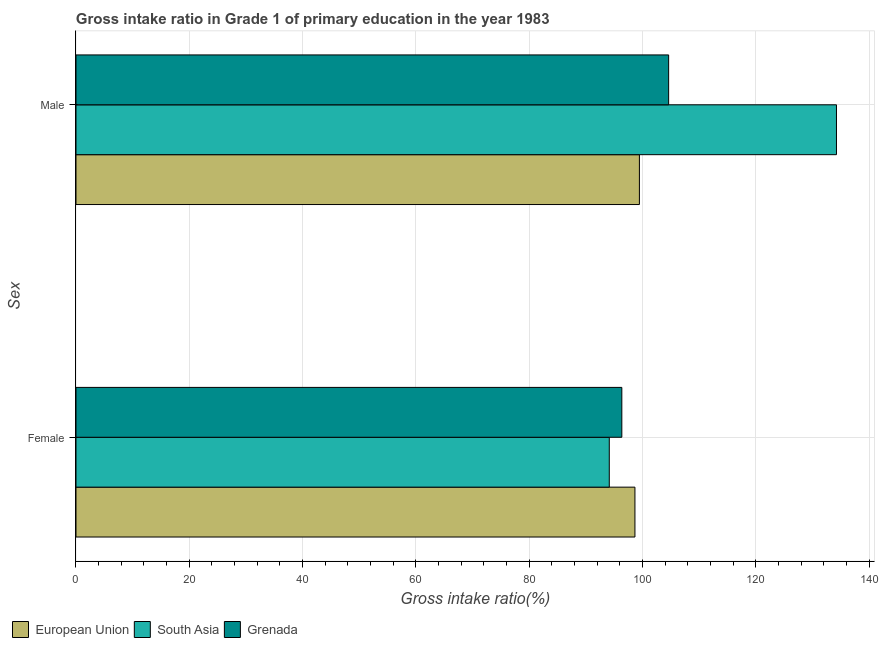How many different coloured bars are there?
Ensure brevity in your answer.  3. How many groups of bars are there?
Give a very brief answer. 2. Are the number of bars per tick equal to the number of legend labels?
Offer a terse response. Yes. Are the number of bars on each tick of the Y-axis equal?
Offer a very short reply. Yes. How many bars are there on the 2nd tick from the bottom?
Your response must be concise. 3. What is the label of the 2nd group of bars from the top?
Your answer should be very brief. Female. What is the gross intake ratio(female) in Grenada?
Your response must be concise. 96.35. Across all countries, what is the maximum gross intake ratio(male)?
Make the answer very short. 134.24. Across all countries, what is the minimum gross intake ratio(male)?
Offer a very short reply. 99.46. In which country was the gross intake ratio(female) minimum?
Your answer should be compact. South Asia. What is the total gross intake ratio(male) in the graph?
Offer a terse response. 338.32. What is the difference between the gross intake ratio(female) in European Union and that in South Asia?
Your answer should be compact. 4.53. What is the difference between the gross intake ratio(female) in European Union and the gross intake ratio(male) in Grenada?
Your response must be concise. -5.95. What is the average gross intake ratio(male) per country?
Provide a succinct answer. 112.77. What is the difference between the gross intake ratio(female) and gross intake ratio(male) in South Asia?
Your response must be concise. -40.11. In how many countries, is the gross intake ratio(male) greater than 16 %?
Provide a short and direct response. 3. What is the ratio of the gross intake ratio(male) in European Union to that in South Asia?
Your response must be concise. 0.74. What does the 3rd bar from the top in Female represents?
Provide a succinct answer. European Union. How many countries are there in the graph?
Give a very brief answer. 3. What is the difference between two consecutive major ticks on the X-axis?
Your response must be concise. 20. Are the values on the major ticks of X-axis written in scientific E-notation?
Give a very brief answer. No. What is the title of the graph?
Make the answer very short. Gross intake ratio in Grade 1 of primary education in the year 1983. Does "Swaziland" appear as one of the legend labels in the graph?
Offer a terse response. No. What is the label or title of the X-axis?
Offer a terse response. Gross intake ratio(%). What is the label or title of the Y-axis?
Your response must be concise. Sex. What is the Gross intake ratio(%) of European Union in Female?
Your answer should be very brief. 98.67. What is the Gross intake ratio(%) in South Asia in Female?
Keep it short and to the point. 94.14. What is the Gross intake ratio(%) in Grenada in Female?
Offer a very short reply. 96.35. What is the Gross intake ratio(%) in European Union in Male?
Provide a succinct answer. 99.46. What is the Gross intake ratio(%) of South Asia in Male?
Provide a succinct answer. 134.24. What is the Gross intake ratio(%) of Grenada in Male?
Your response must be concise. 104.62. Across all Sex, what is the maximum Gross intake ratio(%) in European Union?
Your response must be concise. 99.46. Across all Sex, what is the maximum Gross intake ratio(%) in South Asia?
Provide a short and direct response. 134.24. Across all Sex, what is the maximum Gross intake ratio(%) of Grenada?
Keep it short and to the point. 104.62. Across all Sex, what is the minimum Gross intake ratio(%) in European Union?
Ensure brevity in your answer.  98.67. Across all Sex, what is the minimum Gross intake ratio(%) of South Asia?
Provide a succinct answer. 94.14. Across all Sex, what is the minimum Gross intake ratio(%) of Grenada?
Keep it short and to the point. 96.35. What is the total Gross intake ratio(%) of European Union in the graph?
Make the answer very short. 198.13. What is the total Gross intake ratio(%) of South Asia in the graph?
Your response must be concise. 228.38. What is the total Gross intake ratio(%) in Grenada in the graph?
Give a very brief answer. 200.97. What is the difference between the Gross intake ratio(%) in European Union in Female and that in Male?
Keep it short and to the point. -0.79. What is the difference between the Gross intake ratio(%) in South Asia in Female and that in Male?
Your response must be concise. -40.11. What is the difference between the Gross intake ratio(%) of Grenada in Female and that in Male?
Offer a very short reply. -8.26. What is the difference between the Gross intake ratio(%) in European Union in Female and the Gross intake ratio(%) in South Asia in Male?
Keep it short and to the point. -35.58. What is the difference between the Gross intake ratio(%) of European Union in Female and the Gross intake ratio(%) of Grenada in Male?
Your answer should be compact. -5.95. What is the difference between the Gross intake ratio(%) of South Asia in Female and the Gross intake ratio(%) of Grenada in Male?
Your answer should be compact. -10.48. What is the average Gross intake ratio(%) of European Union per Sex?
Ensure brevity in your answer.  99.06. What is the average Gross intake ratio(%) of South Asia per Sex?
Make the answer very short. 114.19. What is the average Gross intake ratio(%) in Grenada per Sex?
Offer a terse response. 100.49. What is the difference between the Gross intake ratio(%) of European Union and Gross intake ratio(%) of South Asia in Female?
Keep it short and to the point. 4.53. What is the difference between the Gross intake ratio(%) in European Union and Gross intake ratio(%) in Grenada in Female?
Ensure brevity in your answer.  2.31. What is the difference between the Gross intake ratio(%) of South Asia and Gross intake ratio(%) of Grenada in Female?
Provide a succinct answer. -2.22. What is the difference between the Gross intake ratio(%) of European Union and Gross intake ratio(%) of South Asia in Male?
Offer a terse response. -34.79. What is the difference between the Gross intake ratio(%) in European Union and Gross intake ratio(%) in Grenada in Male?
Offer a terse response. -5.16. What is the difference between the Gross intake ratio(%) of South Asia and Gross intake ratio(%) of Grenada in Male?
Your response must be concise. 29.63. What is the ratio of the Gross intake ratio(%) in South Asia in Female to that in Male?
Offer a terse response. 0.7. What is the ratio of the Gross intake ratio(%) in Grenada in Female to that in Male?
Offer a very short reply. 0.92. What is the difference between the highest and the second highest Gross intake ratio(%) of European Union?
Offer a terse response. 0.79. What is the difference between the highest and the second highest Gross intake ratio(%) in South Asia?
Your answer should be compact. 40.11. What is the difference between the highest and the second highest Gross intake ratio(%) of Grenada?
Your answer should be compact. 8.26. What is the difference between the highest and the lowest Gross intake ratio(%) of European Union?
Offer a very short reply. 0.79. What is the difference between the highest and the lowest Gross intake ratio(%) in South Asia?
Make the answer very short. 40.11. What is the difference between the highest and the lowest Gross intake ratio(%) of Grenada?
Ensure brevity in your answer.  8.26. 